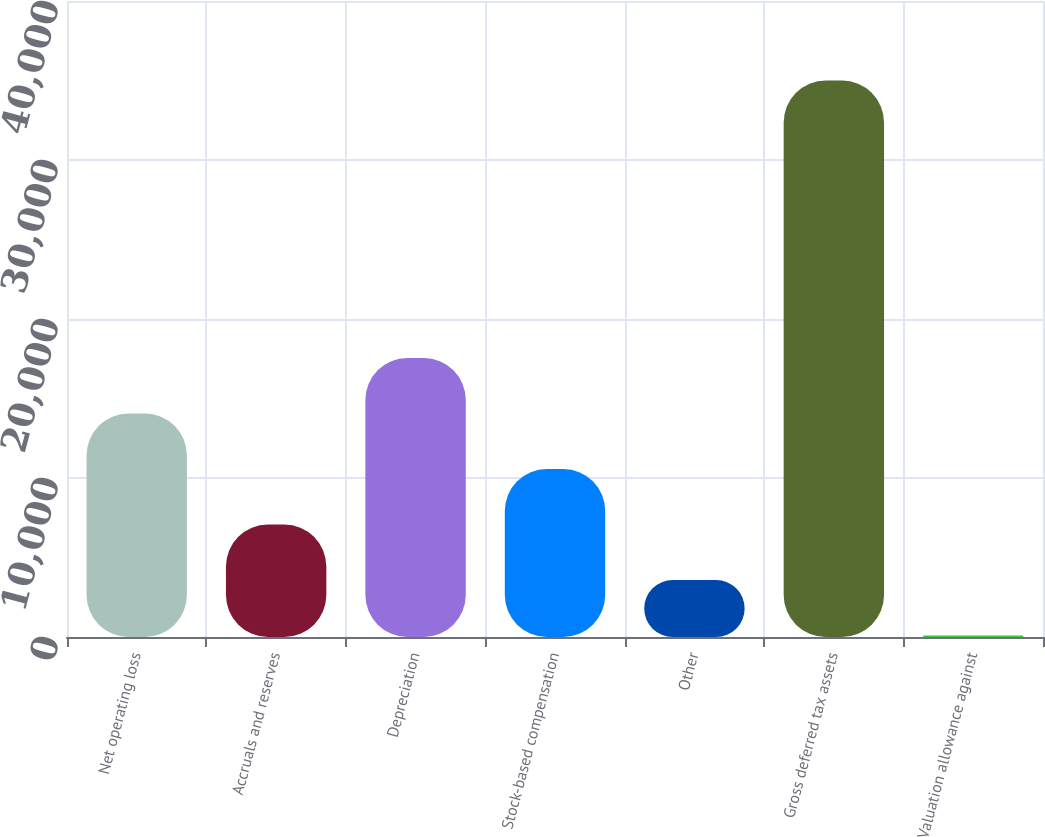Convert chart to OTSL. <chart><loc_0><loc_0><loc_500><loc_500><bar_chart><fcel>Net operating loss<fcel>Accruals and reserves<fcel>Depreciation<fcel>Stock-based compensation<fcel>Other<fcel>Gross deferred tax assets<fcel>Valuation allowance against<nl><fcel>14058<fcel>7077<fcel>17548.5<fcel>10567.5<fcel>3586.5<fcel>35001<fcel>96<nl></chart> 